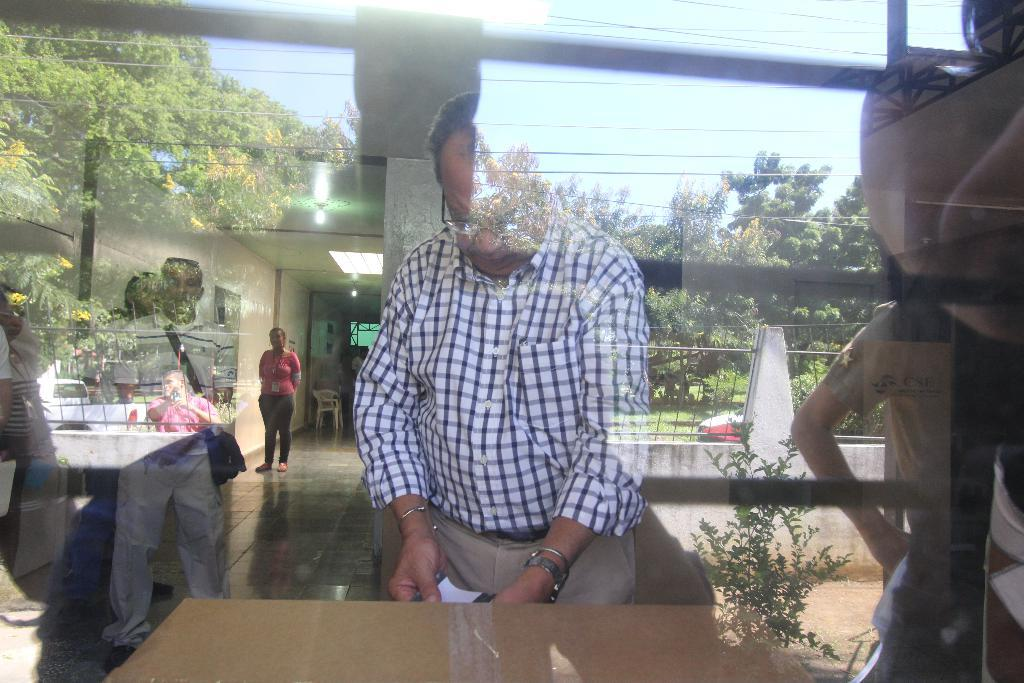What type of wall is present in the image? There is a glass wall in the image. What can be seen through the glass wall? Many people and chairs are visible through the glass wall. What is reflected on the glass wall? There is a reflection of trees and the sky on the glass wall. Where is the chain hanging in the image? There is no chain present in the image. What type of vase is on the table in the image? There is no vase present in the image. 